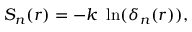Convert formula to latex. <formula><loc_0><loc_0><loc_500><loc_500>S _ { n } ( r ) = - k \ \ln ( \delta _ { n } ( r ) ) ,</formula> 